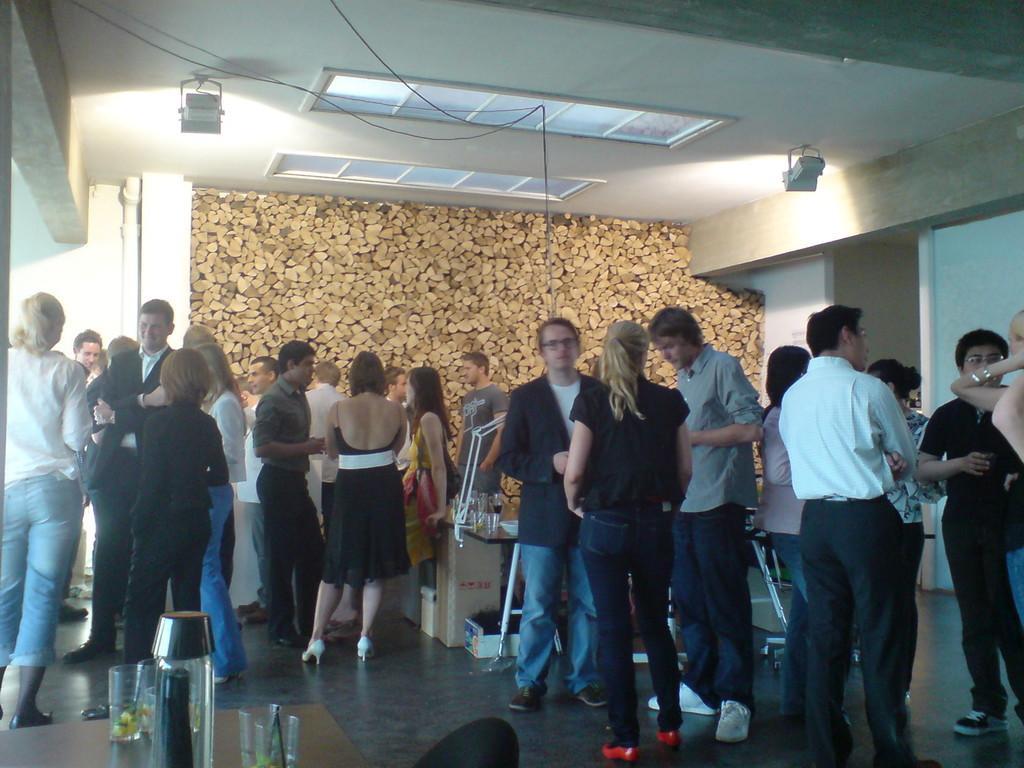How would you summarize this image in a sentence or two? In this image we can see people standing on the floor. To the left side of the image there is a table with glasses. In the background of the image there is wall. There are wooden logs. At the top of the image there is ceiling with lights. 